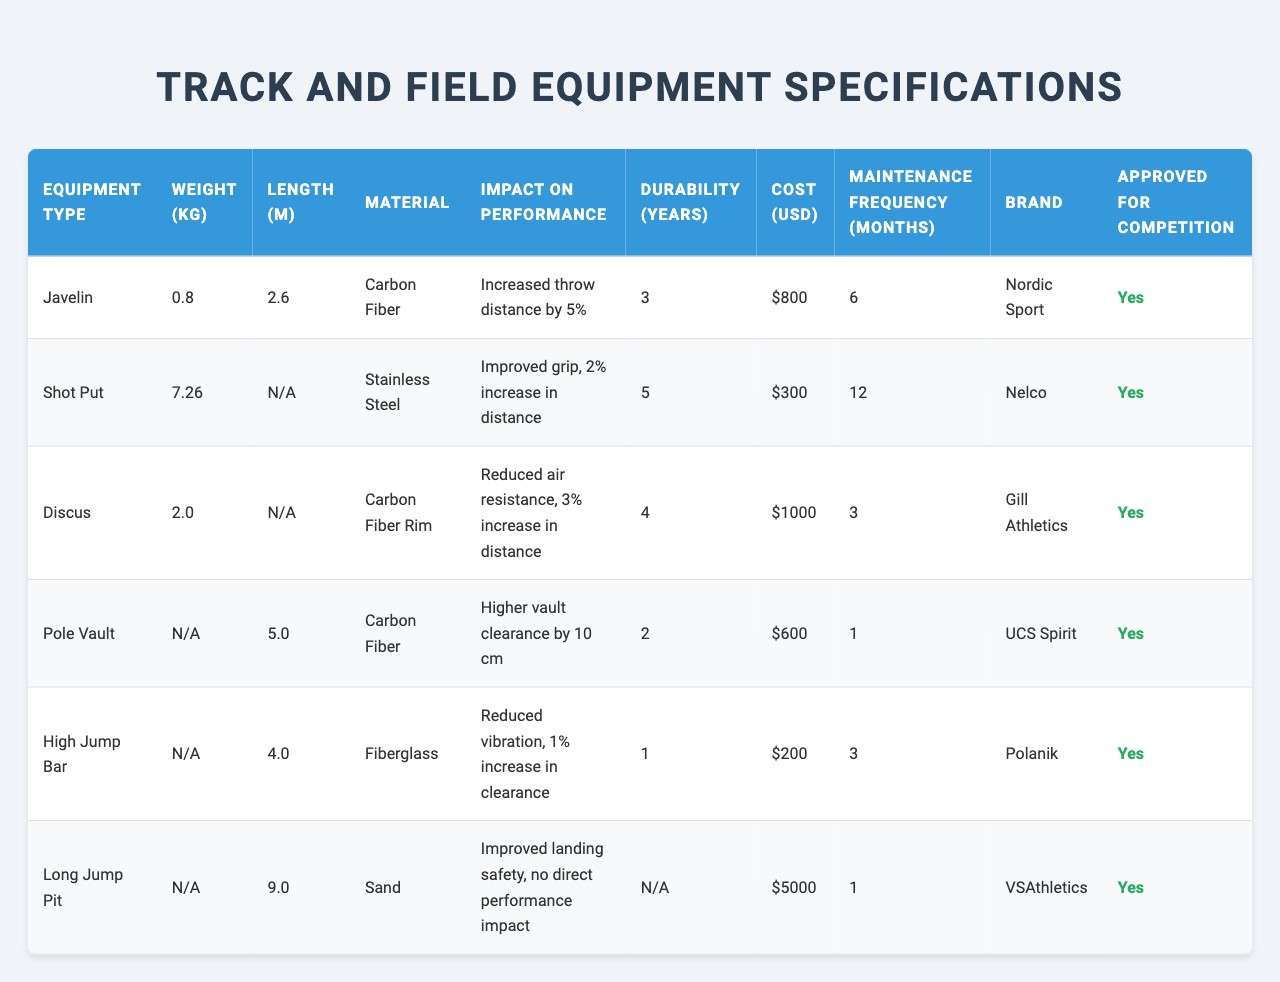What is the weight of the Javelin? The table lists the weight of the Javelin as 0.8 kg.
Answer: 0.8 kg What material is used for the Shot Put? The table specifies that the Shot Put is made of Stainless Steel.
Answer: Stainless Steel How long is the Pole Vault? The length of the Pole Vault is recorded as 5.0 m in the table.
Answer: 5.0 m Which equipment increases performance by the highest percentage? The data indicates that the Pole Vault achieves a higher vault clearance by 10 cm, which is more significant than any other equipment's performance impact.
Answer: Pole Vault What is the cost of the Long Jump Pit? The table shows that the Long Jump Pit costs $5,000.
Answer: $5,000 Is the Javelin approved for competition? Yes, the table confirms that the Javelin is approved for competition.
Answer: Yes What is the impact on performance for the High Jump Bar? The High Jump Bar reduces vibration, providing a 1% increase in clearance as detailed in the table.
Answer: 1% increase in clearance What is the maintenance frequency for the Discus? The table indicates that the maintenance frequency for the Discus is every 3 months.
Answer: 3 months Which equipment has the longest durability? Comparing the durability values listed, the Shot Put has the longest durability at 5 years.
Answer: Shot Put What is the average cost of the equipment types listed? The total cost of all equipment types is $800 + $300 + $1,000 + $600 + $200 + $5,000 = $7,900, and dividing by 6 gives an average cost of $1,316.67.
Answer: $1,316.67 Are there any equipment types that have a durability of N/A? Yes, both the High Jump Bar and Long Jump Pit have their durability marked as N/A in the table.
Answer: Yes What is the difference in weight between the Shot Put and the Javelin? The weight of the Shot Put is 7.26 kg, and the Javelin is 0.8 kg; the difference is 7.26 - 0.8 = 6.46 kg.
Answer: 6.46 kg Which equipment type made from Carbon Fiber has a higher impact on performance, Javelin or Pole Vault? The Javelin increases throw distance by 5%, while the Pole Vault increases vault clearance by 10 cm. Though percentages aren't provided for the Pole Vault, the 10 cm increase can be visualized as higher performance. Therefore, the Pole Vault likely has a higher impact on performance.
Answer: Pole Vault What percentage increase in distance does the Discus provide compared to the Shot Put? The Discus provides a 3% increase in distance, while the Shot Put provides a 2% increase. The difference is 3% - 2% = 1%.
Answer: 1% increase in favor of Discus 